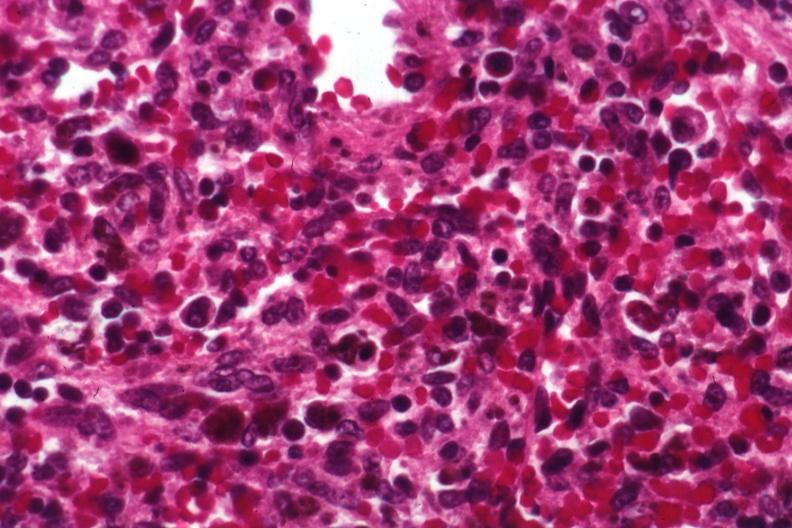s hematologic present?
Answer the question using a single word or phrase. Yes 